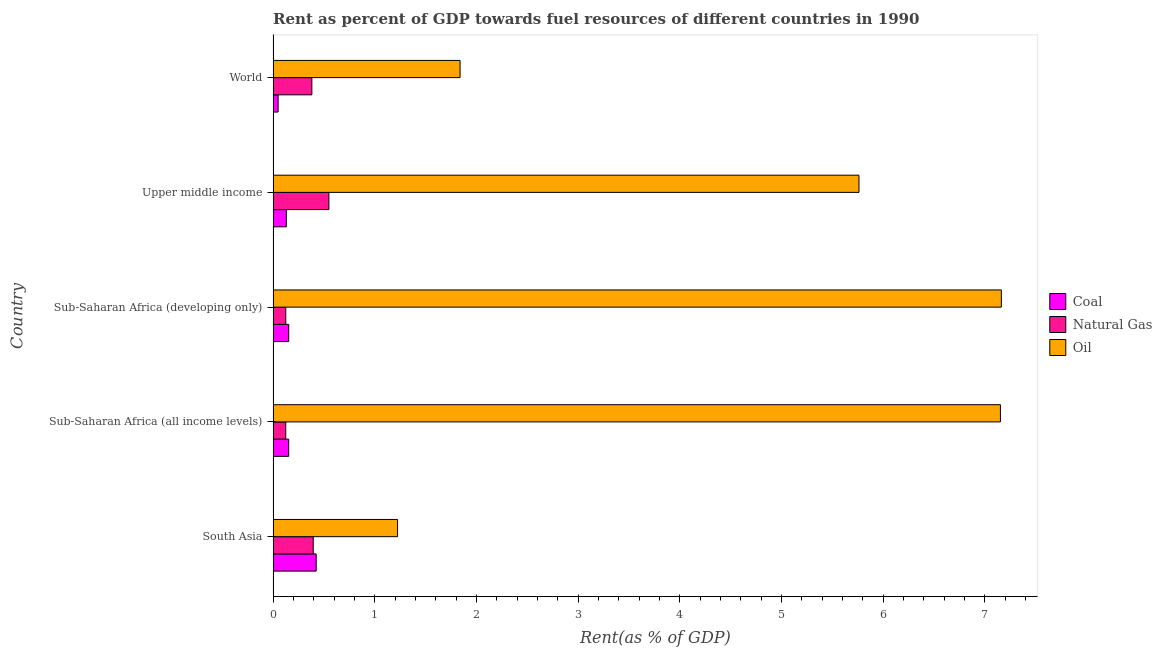How many different coloured bars are there?
Your response must be concise. 3. How many groups of bars are there?
Your answer should be compact. 5. Are the number of bars per tick equal to the number of legend labels?
Offer a terse response. Yes. How many bars are there on the 3rd tick from the top?
Give a very brief answer. 3. What is the label of the 2nd group of bars from the top?
Your response must be concise. Upper middle income. What is the rent towards natural gas in World?
Ensure brevity in your answer.  0.38. Across all countries, what is the maximum rent towards oil?
Give a very brief answer. 7.16. Across all countries, what is the minimum rent towards oil?
Your answer should be very brief. 1.22. In which country was the rent towards natural gas minimum?
Your answer should be compact. Sub-Saharan Africa (all income levels). What is the total rent towards oil in the graph?
Offer a terse response. 23.14. What is the difference between the rent towards oil in South Asia and that in Sub-Saharan Africa (all income levels)?
Offer a very short reply. -5.93. What is the difference between the rent towards natural gas in World and the rent towards oil in Sub-Saharan Africa (developing only)?
Your answer should be very brief. -6.78. What is the average rent towards oil per country?
Give a very brief answer. 4.63. What is the difference between the rent towards coal and rent towards natural gas in Sub-Saharan Africa (developing only)?
Your response must be concise. 0.03. In how many countries, is the rent towards coal greater than 4.4 %?
Keep it short and to the point. 0. What is the ratio of the rent towards oil in South Asia to that in Sub-Saharan Africa (all income levels)?
Provide a short and direct response. 0.17. What is the difference between the highest and the second highest rent towards coal?
Offer a very short reply. 0.27. What is the difference between the highest and the lowest rent towards oil?
Ensure brevity in your answer.  5.94. In how many countries, is the rent towards coal greater than the average rent towards coal taken over all countries?
Give a very brief answer. 1. Is the sum of the rent towards coal in South Asia and Upper middle income greater than the maximum rent towards natural gas across all countries?
Make the answer very short. Yes. What does the 2nd bar from the top in Upper middle income represents?
Your answer should be very brief. Natural Gas. What does the 1st bar from the bottom in South Asia represents?
Offer a terse response. Coal. Are all the bars in the graph horizontal?
Keep it short and to the point. Yes. What is the difference between two consecutive major ticks on the X-axis?
Your answer should be compact. 1. Does the graph contain any zero values?
Offer a very short reply. No. Does the graph contain grids?
Give a very brief answer. No. Where does the legend appear in the graph?
Give a very brief answer. Center right. How many legend labels are there?
Keep it short and to the point. 3. What is the title of the graph?
Your answer should be compact. Rent as percent of GDP towards fuel resources of different countries in 1990. Does "Methane" appear as one of the legend labels in the graph?
Give a very brief answer. No. What is the label or title of the X-axis?
Give a very brief answer. Rent(as % of GDP). What is the Rent(as % of GDP) of Coal in South Asia?
Offer a terse response. 0.42. What is the Rent(as % of GDP) of Natural Gas in South Asia?
Your answer should be very brief. 0.39. What is the Rent(as % of GDP) of Oil in South Asia?
Your answer should be very brief. 1.22. What is the Rent(as % of GDP) in Coal in Sub-Saharan Africa (all income levels)?
Ensure brevity in your answer.  0.15. What is the Rent(as % of GDP) of Natural Gas in Sub-Saharan Africa (all income levels)?
Give a very brief answer. 0.12. What is the Rent(as % of GDP) in Oil in Sub-Saharan Africa (all income levels)?
Your answer should be compact. 7.15. What is the Rent(as % of GDP) in Coal in Sub-Saharan Africa (developing only)?
Your response must be concise. 0.15. What is the Rent(as % of GDP) of Natural Gas in Sub-Saharan Africa (developing only)?
Your response must be concise. 0.12. What is the Rent(as % of GDP) in Oil in Sub-Saharan Africa (developing only)?
Offer a terse response. 7.16. What is the Rent(as % of GDP) in Coal in Upper middle income?
Give a very brief answer. 0.13. What is the Rent(as % of GDP) in Natural Gas in Upper middle income?
Ensure brevity in your answer.  0.55. What is the Rent(as % of GDP) of Oil in Upper middle income?
Make the answer very short. 5.76. What is the Rent(as % of GDP) in Coal in World?
Your response must be concise. 0.05. What is the Rent(as % of GDP) in Natural Gas in World?
Ensure brevity in your answer.  0.38. What is the Rent(as % of GDP) of Oil in World?
Make the answer very short. 1.84. Across all countries, what is the maximum Rent(as % of GDP) in Coal?
Offer a very short reply. 0.42. Across all countries, what is the maximum Rent(as % of GDP) of Natural Gas?
Your response must be concise. 0.55. Across all countries, what is the maximum Rent(as % of GDP) of Oil?
Provide a short and direct response. 7.16. Across all countries, what is the minimum Rent(as % of GDP) of Coal?
Provide a succinct answer. 0.05. Across all countries, what is the minimum Rent(as % of GDP) of Natural Gas?
Your response must be concise. 0.12. Across all countries, what is the minimum Rent(as % of GDP) in Oil?
Keep it short and to the point. 1.22. What is the total Rent(as % of GDP) in Coal in the graph?
Ensure brevity in your answer.  0.91. What is the total Rent(as % of GDP) in Natural Gas in the graph?
Offer a terse response. 1.57. What is the total Rent(as % of GDP) in Oil in the graph?
Your response must be concise. 23.14. What is the difference between the Rent(as % of GDP) of Coal in South Asia and that in Sub-Saharan Africa (all income levels)?
Provide a short and direct response. 0.27. What is the difference between the Rent(as % of GDP) of Natural Gas in South Asia and that in Sub-Saharan Africa (all income levels)?
Provide a short and direct response. 0.27. What is the difference between the Rent(as % of GDP) in Oil in South Asia and that in Sub-Saharan Africa (all income levels)?
Give a very brief answer. -5.93. What is the difference between the Rent(as % of GDP) of Coal in South Asia and that in Sub-Saharan Africa (developing only)?
Keep it short and to the point. 0.27. What is the difference between the Rent(as % of GDP) of Natural Gas in South Asia and that in Sub-Saharan Africa (developing only)?
Keep it short and to the point. 0.27. What is the difference between the Rent(as % of GDP) of Oil in South Asia and that in Sub-Saharan Africa (developing only)?
Make the answer very short. -5.94. What is the difference between the Rent(as % of GDP) in Coal in South Asia and that in Upper middle income?
Your response must be concise. 0.29. What is the difference between the Rent(as % of GDP) of Natural Gas in South Asia and that in Upper middle income?
Provide a succinct answer. -0.15. What is the difference between the Rent(as % of GDP) of Oil in South Asia and that in Upper middle income?
Keep it short and to the point. -4.54. What is the difference between the Rent(as % of GDP) in Coal in South Asia and that in World?
Your answer should be very brief. 0.37. What is the difference between the Rent(as % of GDP) in Natural Gas in South Asia and that in World?
Offer a terse response. 0.01. What is the difference between the Rent(as % of GDP) in Oil in South Asia and that in World?
Provide a short and direct response. -0.61. What is the difference between the Rent(as % of GDP) in Coal in Sub-Saharan Africa (all income levels) and that in Sub-Saharan Africa (developing only)?
Your answer should be very brief. -0. What is the difference between the Rent(as % of GDP) of Natural Gas in Sub-Saharan Africa (all income levels) and that in Sub-Saharan Africa (developing only)?
Your answer should be compact. -0. What is the difference between the Rent(as % of GDP) of Oil in Sub-Saharan Africa (all income levels) and that in Sub-Saharan Africa (developing only)?
Your answer should be compact. -0.01. What is the difference between the Rent(as % of GDP) of Coal in Sub-Saharan Africa (all income levels) and that in Upper middle income?
Make the answer very short. 0.02. What is the difference between the Rent(as % of GDP) in Natural Gas in Sub-Saharan Africa (all income levels) and that in Upper middle income?
Provide a succinct answer. -0.42. What is the difference between the Rent(as % of GDP) in Oil in Sub-Saharan Africa (all income levels) and that in Upper middle income?
Give a very brief answer. 1.39. What is the difference between the Rent(as % of GDP) in Coal in Sub-Saharan Africa (all income levels) and that in World?
Make the answer very short. 0.1. What is the difference between the Rent(as % of GDP) of Natural Gas in Sub-Saharan Africa (all income levels) and that in World?
Your response must be concise. -0.26. What is the difference between the Rent(as % of GDP) of Oil in Sub-Saharan Africa (all income levels) and that in World?
Provide a short and direct response. 5.31. What is the difference between the Rent(as % of GDP) of Coal in Sub-Saharan Africa (developing only) and that in Upper middle income?
Your response must be concise. 0.02. What is the difference between the Rent(as % of GDP) of Natural Gas in Sub-Saharan Africa (developing only) and that in Upper middle income?
Your response must be concise. -0.42. What is the difference between the Rent(as % of GDP) of Oil in Sub-Saharan Africa (developing only) and that in Upper middle income?
Your answer should be very brief. 1.4. What is the difference between the Rent(as % of GDP) in Coal in Sub-Saharan Africa (developing only) and that in World?
Provide a succinct answer. 0.1. What is the difference between the Rent(as % of GDP) in Natural Gas in Sub-Saharan Africa (developing only) and that in World?
Give a very brief answer. -0.26. What is the difference between the Rent(as % of GDP) of Oil in Sub-Saharan Africa (developing only) and that in World?
Your answer should be very brief. 5.32. What is the difference between the Rent(as % of GDP) of Coal in Upper middle income and that in World?
Keep it short and to the point. 0.08. What is the difference between the Rent(as % of GDP) of Natural Gas in Upper middle income and that in World?
Give a very brief answer. 0.17. What is the difference between the Rent(as % of GDP) of Oil in Upper middle income and that in World?
Offer a very short reply. 3.92. What is the difference between the Rent(as % of GDP) of Coal in South Asia and the Rent(as % of GDP) of Natural Gas in Sub-Saharan Africa (all income levels)?
Your answer should be compact. 0.3. What is the difference between the Rent(as % of GDP) of Coal in South Asia and the Rent(as % of GDP) of Oil in Sub-Saharan Africa (all income levels)?
Ensure brevity in your answer.  -6.73. What is the difference between the Rent(as % of GDP) of Natural Gas in South Asia and the Rent(as % of GDP) of Oil in Sub-Saharan Africa (all income levels)?
Keep it short and to the point. -6.76. What is the difference between the Rent(as % of GDP) in Coal in South Asia and the Rent(as % of GDP) in Natural Gas in Sub-Saharan Africa (developing only)?
Your answer should be compact. 0.3. What is the difference between the Rent(as % of GDP) in Coal in South Asia and the Rent(as % of GDP) in Oil in Sub-Saharan Africa (developing only)?
Make the answer very short. -6.74. What is the difference between the Rent(as % of GDP) in Natural Gas in South Asia and the Rent(as % of GDP) in Oil in Sub-Saharan Africa (developing only)?
Give a very brief answer. -6.77. What is the difference between the Rent(as % of GDP) of Coal in South Asia and the Rent(as % of GDP) of Natural Gas in Upper middle income?
Ensure brevity in your answer.  -0.12. What is the difference between the Rent(as % of GDP) in Coal in South Asia and the Rent(as % of GDP) in Oil in Upper middle income?
Offer a terse response. -5.34. What is the difference between the Rent(as % of GDP) of Natural Gas in South Asia and the Rent(as % of GDP) of Oil in Upper middle income?
Give a very brief answer. -5.37. What is the difference between the Rent(as % of GDP) of Coal in South Asia and the Rent(as % of GDP) of Natural Gas in World?
Provide a short and direct response. 0.04. What is the difference between the Rent(as % of GDP) in Coal in South Asia and the Rent(as % of GDP) in Oil in World?
Your answer should be compact. -1.41. What is the difference between the Rent(as % of GDP) of Natural Gas in South Asia and the Rent(as % of GDP) of Oil in World?
Keep it short and to the point. -1.44. What is the difference between the Rent(as % of GDP) of Coal in Sub-Saharan Africa (all income levels) and the Rent(as % of GDP) of Natural Gas in Sub-Saharan Africa (developing only)?
Your answer should be very brief. 0.03. What is the difference between the Rent(as % of GDP) of Coal in Sub-Saharan Africa (all income levels) and the Rent(as % of GDP) of Oil in Sub-Saharan Africa (developing only)?
Give a very brief answer. -7.01. What is the difference between the Rent(as % of GDP) in Natural Gas in Sub-Saharan Africa (all income levels) and the Rent(as % of GDP) in Oil in Sub-Saharan Africa (developing only)?
Offer a very short reply. -7.04. What is the difference between the Rent(as % of GDP) in Coal in Sub-Saharan Africa (all income levels) and the Rent(as % of GDP) in Natural Gas in Upper middle income?
Ensure brevity in your answer.  -0.4. What is the difference between the Rent(as % of GDP) in Coal in Sub-Saharan Africa (all income levels) and the Rent(as % of GDP) in Oil in Upper middle income?
Offer a very short reply. -5.61. What is the difference between the Rent(as % of GDP) of Natural Gas in Sub-Saharan Africa (all income levels) and the Rent(as % of GDP) of Oil in Upper middle income?
Ensure brevity in your answer.  -5.64. What is the difference between the Rent(as % of GDP) of Coal in Sub-Saharan Africa (all income levels) and the Rent(as % of GDP) of Natural Gas in World?
Your answer should be very brief. -0.23. What is the difference between the Rent(as % of GDP) of Coal in Sub-Saharan Africa (all income levels) and the Rent(as % of GDP) of Oil in World?
Give a very brief answer. -1.69. What is the difference between the Rent(as % of GDP) in Natural Gas in Sub-Saharan Africa (all income levels) and the Rent(as % of GDP) in Oil in World?
Your answer should be compact. -1.71. What is the difference between the Rent(as % of GDP) in Coal in Sub-Saharan Africa (developing only) and the Rent(as % of GDP) in Natural Gas in Upper middle income?
Make the answer very short. -0.39. What is the difference between the Rent(as % of GDP) in Coal in Sub-Saharan Africa (developing only) and the Rent(as % of GDP) in Oil in Upper middle income?
Offer a very short reply. -5.61. What is the difference between the Rent(as % of GDP) in Natural Gas in Sub-Saharan Africa (developing only) and the Rent(as % of GDP) in Oil in Upper middle income?
Your answer should be very brief. -5.64. What is the difference between the Rent(as % of GDP) in Coal in Sub-Saharan Africa (developing only) and the Rent(as % of GDP) in Natural Gas in World?
Ensure brevity in your answer.  -0.23. What is the difference between the Rent(as % of GDP) in Coal in Sub-Saharan Africa (developing only) and the Rent(as % of GDP) in Oil in World?
Ensure brevity in your answer.  -1.69. What is the difference between the Rent(as % of GDP) in Natural Gas in Sub-Saharan Africa (developing only) and the Rent(as % of GDP) in Oil in World?
Your answer should be very brief. -1.71. What is the difference between the Rent(as % of GDP) of Coal in Upper middle income and the Rent(as % of GDP) of Natural Gas in World?
Your answer should be compact. -0.25. What is the difference between the Rent(as % of GDP) of Coal in Upper middle income and the Rent(as % of GDP) of Oil in World?
Give a very brief answer. -1.71. What is the difference between the Rent(as % of GDP) of Natural Gas in Upper middle income and the Rent(as % of GDP) of Oil in World?
Provide a succinct answer. -1.29. What is the average Rent(as % of GDP) of Coal per country?
Provide a short and direct response. 0.18. What is the average Rent(as % of GDP) in Natural Gas per country?
Ensure brevity in your answer.  0.31. What is the average Rent(as % of GDP) in Oil per country?
Your response must be concise. 4.63. What is the difference between the Rent(as % of GDP) in Coal and Rent(as % of GDP) in Natural Gas in South Asia?
Give a very brief answer. 0.03. What is the difference between the Rent(as % of GDP) of Coal and Rent(as % of GDP) of Oil in South Asia?
Your answer should be very brief. -0.8. What is the difference between the Rent(as % of GDP) in Natural Gas and Rent(as % of GDP) in Oil in South Asia?
Keep it short and to the point. -0.83. What is the difference between the Rent(as % of GDP) in Coal and Rent(as % of GDP) in Natural Gas in Sub-Saharan Africa (all income levels)?
Ensure brevity in your answer.  0.03. What is the difference between the Rent(as % of GDP) in Coal and Rent(as % of GDP) in Oil in Sub-Saharan Africa (all income levels)?
Offer a very short reply. -7. What is the difference between the Rent(as % of GDP) in Natural Gas and Rent(as % of GDP) in Oil in Sub-Saharan Africa (all income levels)?
Provide a short and direct response. -7.03. What is the difference between the Rent(as % of GDP) in Coal and Rent(as % of GDP) in Natural Gas in Sub-Saharan Africa (developing only)?
Make the answer very short. 0.03. What is the difference between the Rent(as % of GDP) of Coal and Rent(as % of GDP) of Oil in Sub-Saharan Africa (developing only)?
Ensure brevity in your answer.  -7.01. What is the difference between the Rent(as % of GDP) of Natural Gas and Rent(as % of GDP) of Oil in Sub-Saharan Africa (developing only)?
Keep it short and to the point. -7.04. What is the difference between the Rent(as % of GDP) of Coal and Rent(as % of GDP) of Natural Gas in Upper middle income?
Provide a succinct answer. -0.42. What is the difference between the Rent(as % of GDP) in Coal and Rent(as % of GDP) in Oil in Upper middle income?
Provide a short and direct response. -5.63. What is the difference between the Rent(as % of GDP) of Natural Gas and Rent(as % of GDP) of Oil in Upper middle income?
Offer a very short reply. -5.21. What is the difference between the Rent(as % of GDP) of Coal and Rent(as % of GDP) of Natural Gas in World?
Your response must be concise. -0.33. What is the difference between the Rent(as % of GDP) of Coal and Rent(as % of GDP) of Oil in World?
Offer a terse response. -1.79. What is the difference between the Rent(as % of GDP) in Natural Gas and Rent(as % of GDP) in Oil in World?
Make the answer very short. -1.46. What is the ratio of the Rent(as % of GDP) in Coal in South Asia to that in Sub-Saharan Africa (all income levels)?
Offer a very short reply. 2.77. What is the ratio of the Rent(as % of GDP) in Natural Gas in South Asia to that in Sub-Saharan Africa (all income levels)?
Provide a short and direct response. 3.17. What is the ratio of the Rent(as % of GDP) of Oil in South Asia to that in Sub-Saharan Africa (all income levels)?
Provide a succinct answer. 0.17. What is the ratio of the Rent(as % of GDP) in Coal in South Asia to that in Sub-Saharan Africa (developing only)?
Your answer should be compact. 2.76. What is the ratio of the Rent(as % of GDP) of Natural Gas in South Asia to that in Sub-Saharan Africa (developing only)?
Give a very brief answer. 3.17. What is the ratio of the Rent(as % of GDP) in Oil in South Asia to that in Sub-Saharan Africa (developing only)?
Offer a very short reply. 0.17. What is the ratio of the Rent(as % of GDP) of Coal in South Asia to that in Upper middle income?
Ensure brevity in your answer.  3.26. What is the ratio of the Rent(as % of GDP) in Natural Gas in South Asia to that in Upper middle income?
Give a very brief answer. 0.72. What is the ratio of the Rent(as % of GDP) of Oil in South Asia to that in Upper middle income?
Provide a succinct answer. 0.21. What is the ratio of the Rent(as % of GDP) in Coal in South Asia to that in World?
Give a very brief answer. 8.61. What is the ratio of the Rent(as % of GDP) in Natural Gas in South Asia to that in World?
Give a very brief answer. 1.04. What is the ratio of the Rent(as % of GDP) in Oil in South Asia to that in World?
Give a very brief answer. 0.67. What is the ratio of the Rent(as % of GDP) of Coal in Sub-Saharan Africa (all income levels) to that in Sub-Saharan Africa (developing only)?
Your answer should be very brief. 1. What is the ratio of the Rent(as % of GDP) in Natural Gas in Sub-Saharan Africa (all income levels) to that in Sub-Saharan Africa (developing only)?
Ensure brevity in your answer.  1. What is the ratio of the Rent(as % of GDP) of Coal in Sub-Saharan Africa (all income levels) to that in Upper middle income?
Your answer should be very brief. 1.18. What is the ratio of the Rent(as % of GDP) in Natural Gas in Sub-Saharan Africa (all income levels) to that in Upper middle income?
Provide a succinct answer. 0.23. What is the ratio of the Rent(as % of GDP) in Oil in Sub-Saharan Africa (all income levels) to that in Upper middle income?
Keep it short and to the point. 1.24. What is the ratio of the Rent(as % of GDP) of Coal in Sub-Saharan Africa (all income levels) to that in World?
Offer a very short reply. 3.11. What is the ratio of the Rent(as % of GDP) of Natural Gas in Sub-Saharan Africa (all income levels) to that in World?
Offer a very short reply. 0.33. What is the ratio of the Rent(as % of GDP) of Oil in Sub-Saharan Africa (all income levels) to that in World?
Offer a very short reply. 3.89. What is the ratio of the Rent(as % of GDP) in Coal in Sub-Saharan Africa (developing only) to that in Upper middle income?
Provide a short and direct response. 1.18. What is the ratio of the Rent(as % of GDP) of Natural Gas in Sub-Saharan Africa (developing only) to that in Upper middle income?
Provide a succinct answer. 0.23. What is the ratio of the Rent(as % of GDP) in Oil in Sub-Saharan Africa (developing only) to that in Upper middle income?
Offer a very short reply. 1.24. What is the ratio of the Rent(as % of GDP) of Coal in Sub-Saharan Africa (developing only) to that in World?
Provide a succinct answer. 3.12. What is the ratio of the Rent(as % of GDP) in Natural Gas in Sub-Saharan Africa (developing only) to that in World?
Provide a short and direct response. 0.33. What is the ratio of the Rent(as % of GDP) of Oil in Sub-Saharan Africa (developing only) to that in World?
Ensure brevity in your answer.  3.9. What is the ratio of the Rent(as % of GDP) in Coal in Upper middle income to that in World?
Keep it short and to the point. 2.64. What is the ratio of the Rent(as % of GDP) of Natural Gas in Upper middle income to that in World?
Ensure brevity in your answer.  1.44. What is the ratio of the Rent(as % of GDP) of Oil in Upper middle income to that in World?
Your answer should be compact. 3.13. What is the difference between the highest and the second highest Rent(as % of GDP) of Coal?
Make the answer very short. 0.27. What is the difference between the highest and the second highest Rent(as % of GDP) in Natural Gas?
Offer a very short reply. 0.15. What is the difference between the highest and the second highest Rent(as % of GDP) in Oil?
Provide a succinct answer. 0.01. What is the difference between the highest and the lowest Rent(as % of GDP) of Coal?
Ensure brevity in your answer.  0.37. What is the difference between the highest and the lowest Rent(as % of GDP) of Natural Gas?
Provide a succinct answer. 0.42. What is the difference between the highest and the lowest Rent(as % of GDP) in Oil?
Keep it short and to the point. 5.94. 